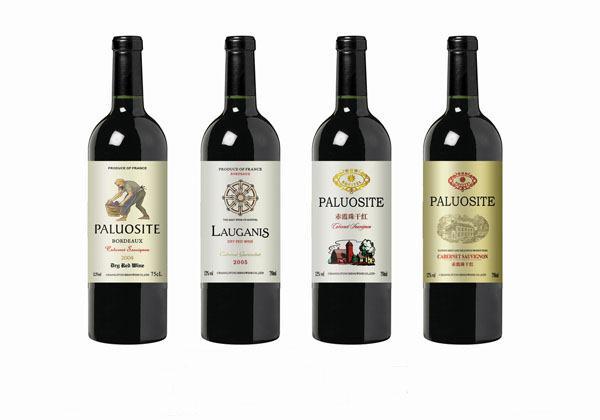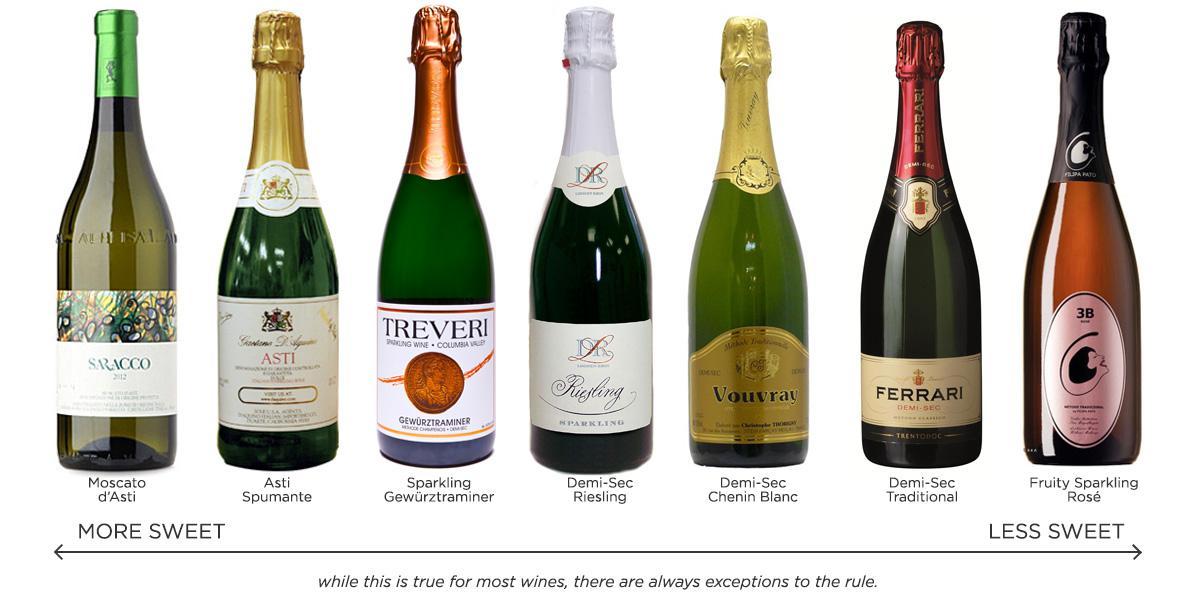The first image is the image on the left, the second image is the image on the right. For the images displayed, is the sentence "One of these images contains exactly four wine bottles." factually correct? Answer yes or no. Yes. The first image is the image on the left, the second image is the image on the right. Analyze the images presented: Is the assertion "There are no more than five wine bottles in the left image." valid? Answer yes or no. Yes. 